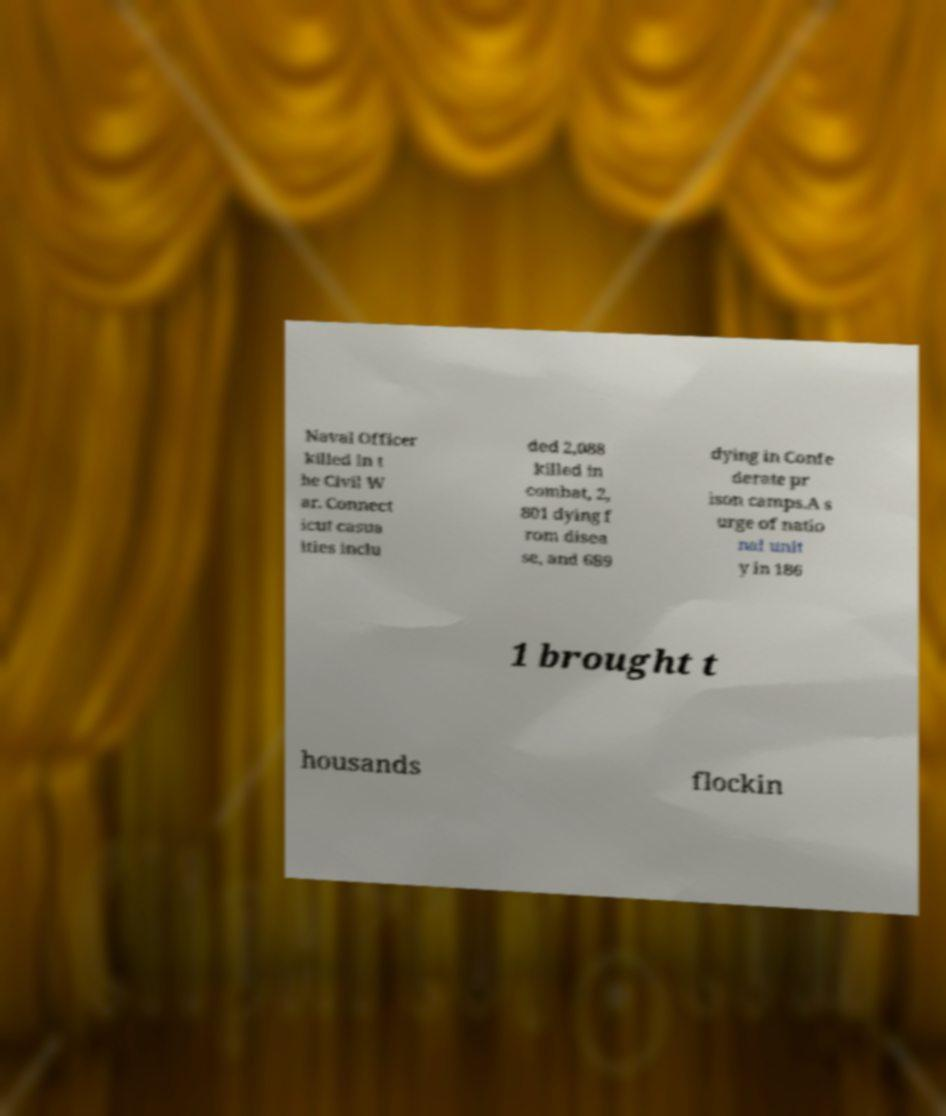Could you extract and type out the text from this image? Naval Officer killed in t he Civil W ar. Connect icut casua lties inclu ded 2,088 killed in combat, 2, 801 dying f rom disea se, and 689 dying in Confe derate pr ison camps.A s urge of natio nal unit y in 186 1 brought t housands flockin 